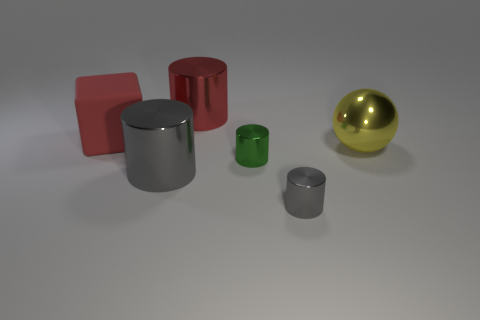What can you tell me about the sizes of the objects compared to each other? The objects vary in size, with the red cylinder and the yellow sphere being the largest. The red cylinder is taller but narrower than the yellow sphere, which is shorter but wider. The green cylinder is noticeably smaller than both, and the two gray cylinders are smaller still, with one being about half the height of the other. 